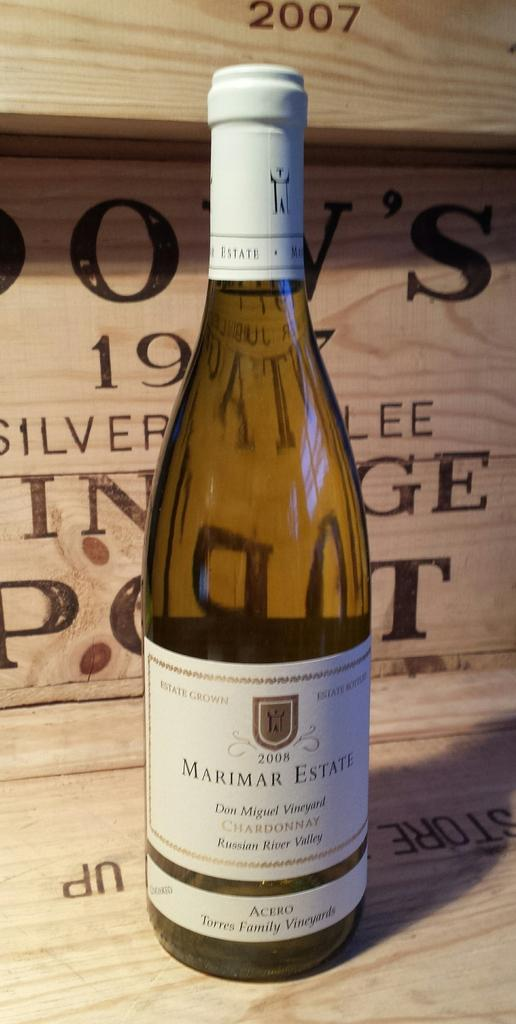Provide a one-sentence caption for the provided image. A wine bottle is from the Don Miguel vineyard, per the label. 